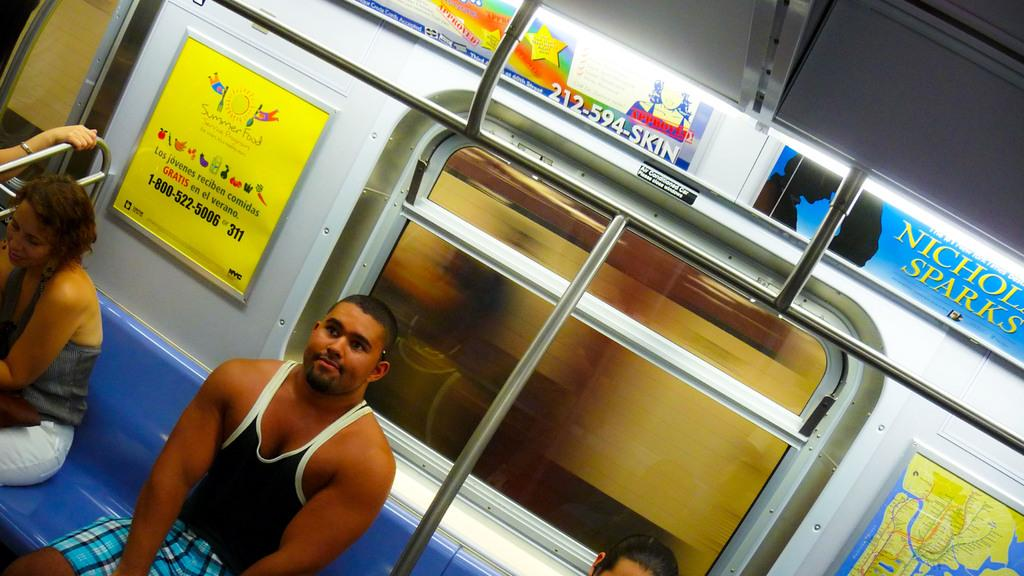<image>
Give a short and clear explanation of the subsequent image. An ad for a Nicholas Sparks book is among other ads above the bus windows. 